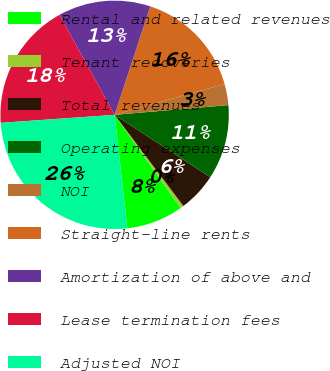Convert chart. <chart><loc_0><loc_0><loc_500><loc_500><pie_chart><fcel>Rental and related revenues<fcel>Tenant recoveries<fcel>Total revenues<fcel>Operating expenses<fcel>NOI<fcel>Straight-line rents<fcel>Amortization of above and<fcel>Lease termination fees<fcel>Adjusted NOI<nl><fcel>8.03%<fcel>0.48%<fcel>5.52%<fcel>10.55%<fcel>3.0%<fcel>15.59%<fcel>13.07%<fcel>18.1%<fcel>25.66%<nl></chart> 